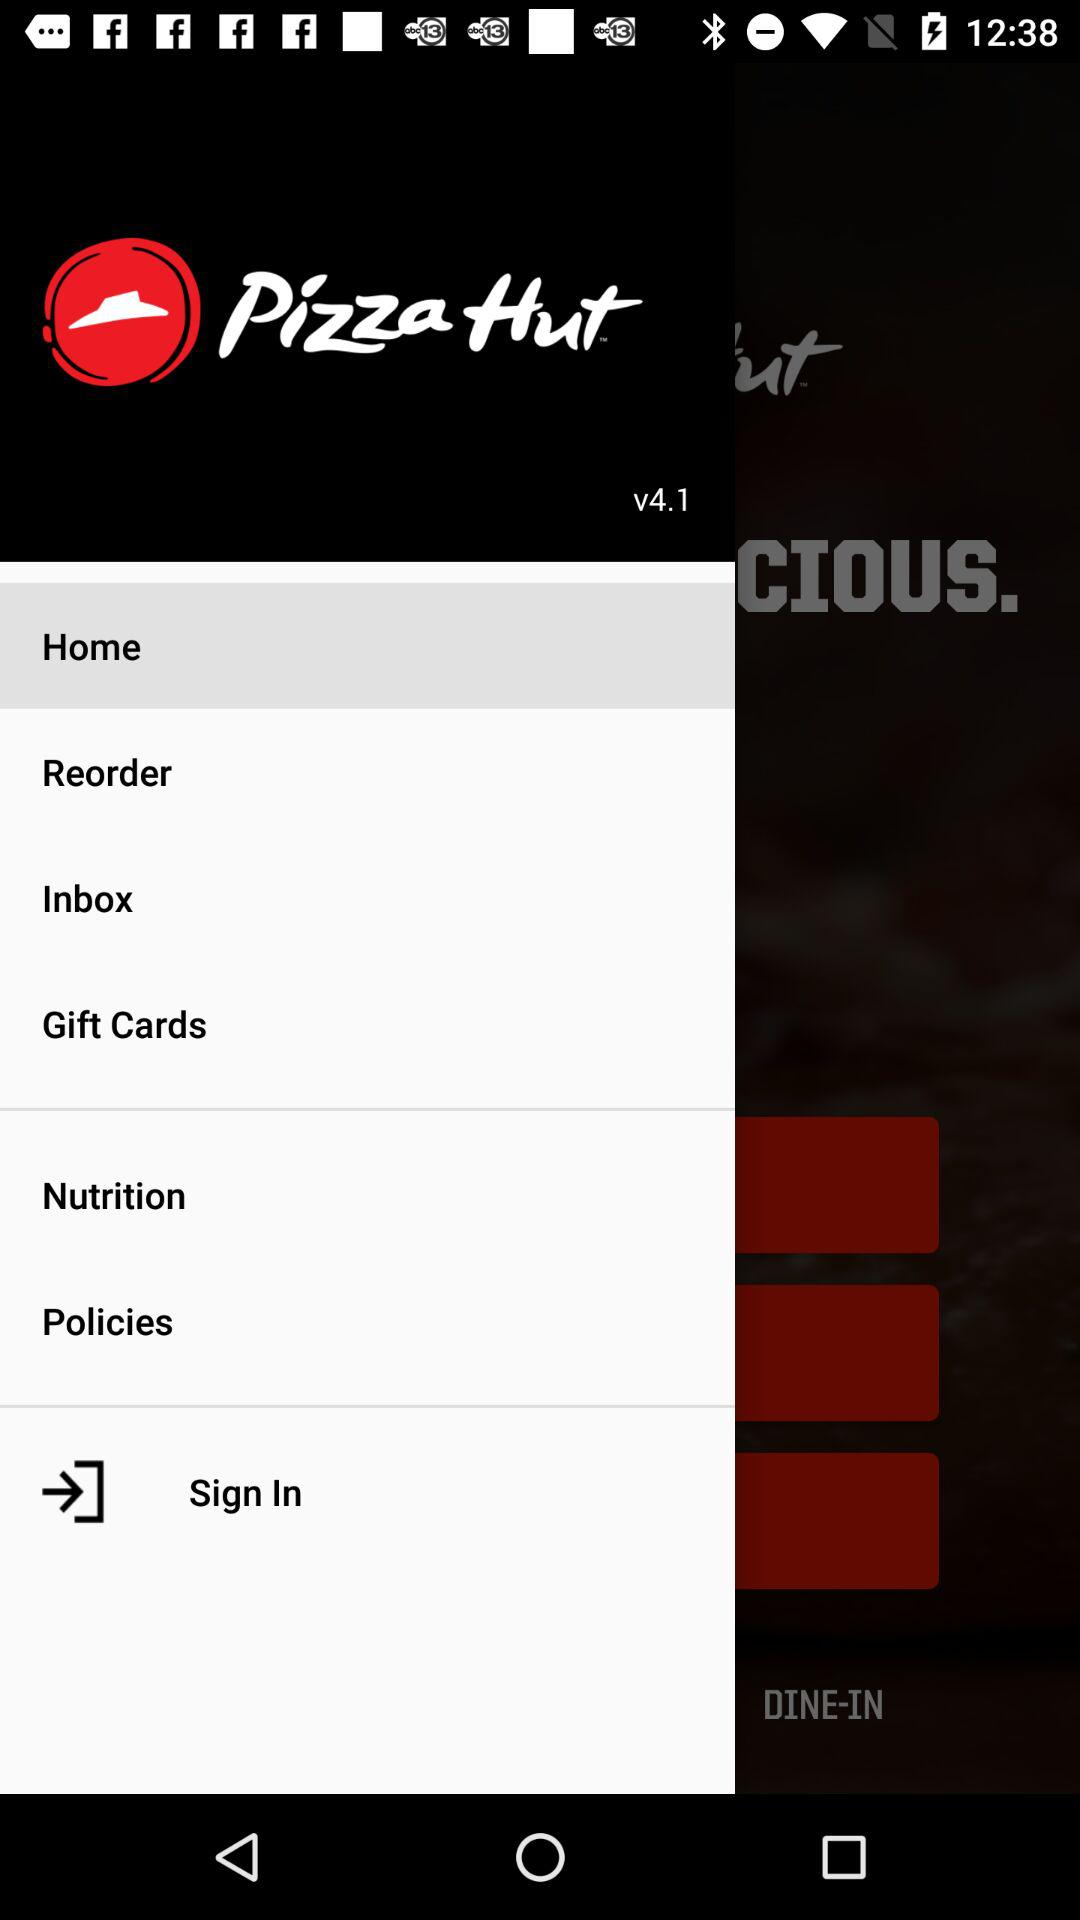Which type of pizza is in the inbox?
When the provided information is insufficient, respond with <no answer>. <no answer> 